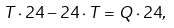<formula> <loc_0><loc_0><loc_500><loc_500>T \cdot { 2 4 } - { 2 4 } \cdot T = Q \cdot { 2 4 } ,</formula> 